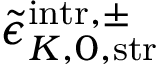Convert formula to latex. <formula><loc_0><loc_0><loc_500><loc_500>\tilde { \epsilon } _ { K , 0 , s t r } ^ { i n t r , \pm }</formula> 